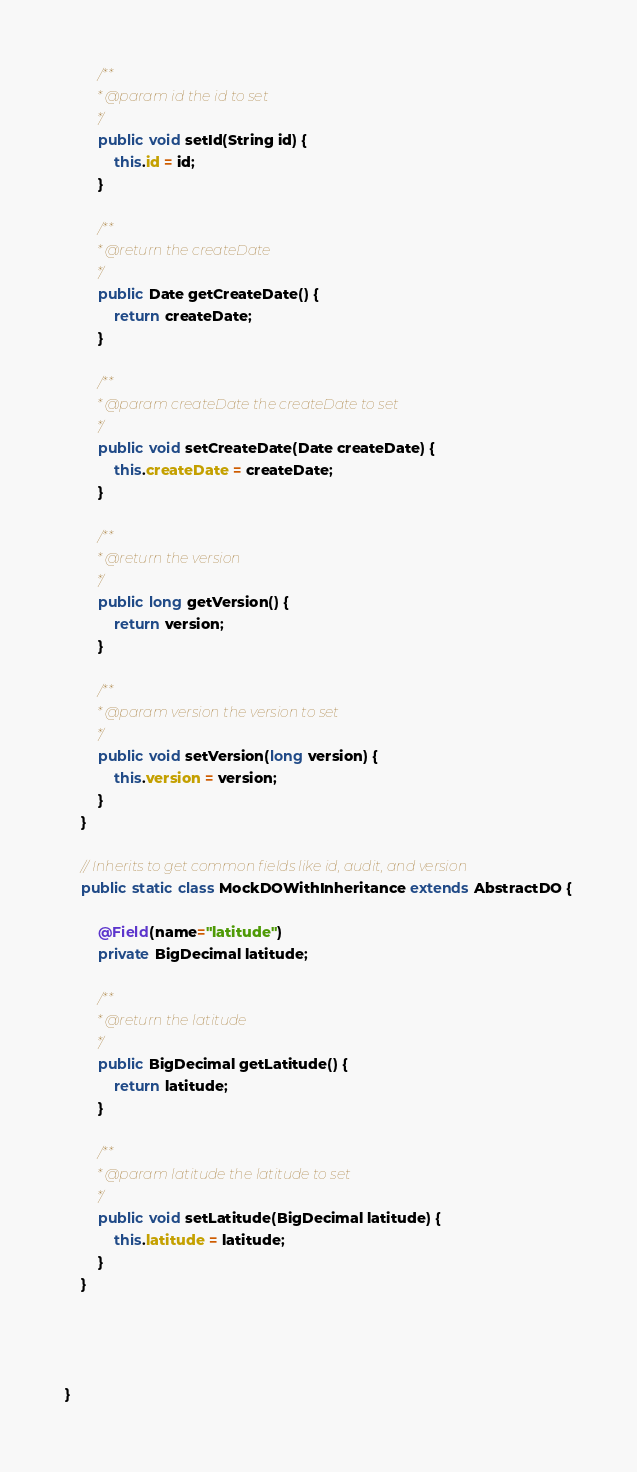<code> <loc_0><loc_0><loc_500><loc_500><_Java_>
		/**
		 * @param id the id to set
		 */
		public void setId(String id) {
			this.id = id;
		}

		/**
		 * @return the createDate
		 */
		public Date getCreateDate() {
			return createDate;
		}

		/**
		 * @param createDate the createDate to set
		 */
		public void setCreateDate(Date createDate) {
			this.createDate = createDate;
		}

		/**
		 * @return the version
		 */
		public long getVersion() {
			return version;
		}

		/**
		 * @param version the version to set
		 */
		public void setVersion(long version) {
			this.version = version;
		}
	}
	
	// Inherits to get common fields like id, audit, and version
	public static class MockDOWithInheritance extends AbstractDO {
		
		@Field(name="latitude")
		private BigDecimal latitude;

		/**
		 * @return the latitude
		 */
		public BigDecimal getLatitude() {
			return latitude;
		}

		/**
		 * @param latitude the latitude to set
		 */
		public void setLatitude(BigDecimal latitude) {
			this.latitude = latitude;
		}
	}
	
	
	
	
}
</code> 